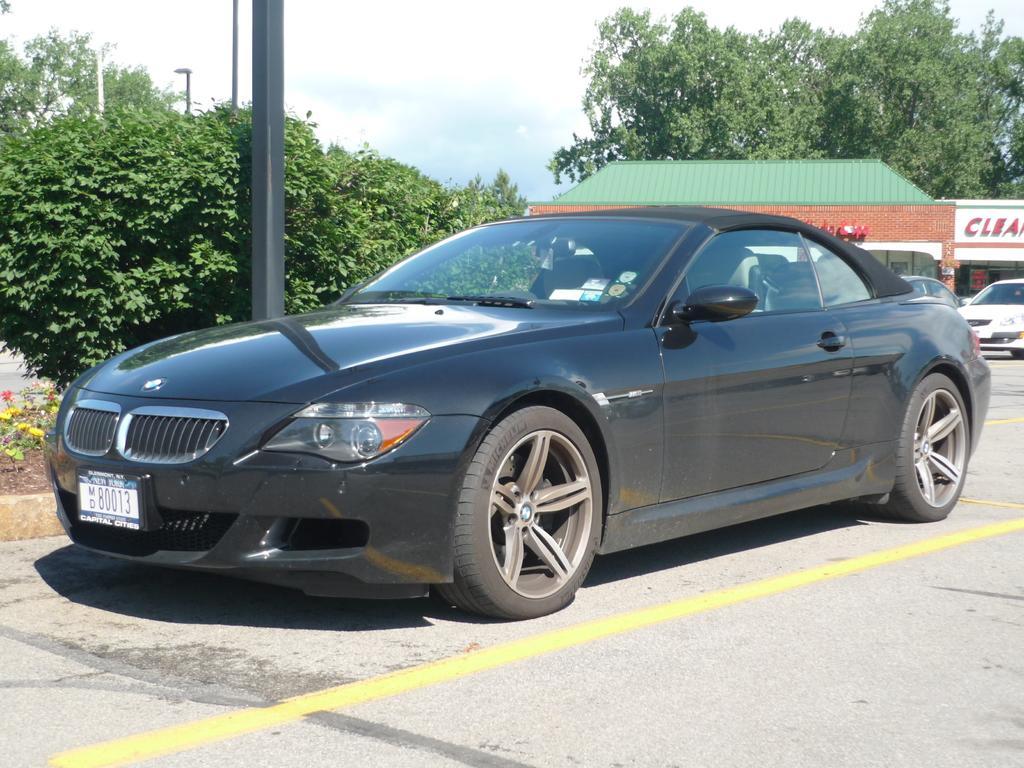Please provide a concise description of this image. In the picture I can see vehicles on the ground among them the car in front of the image is black in color. In the background I can see trees, poles, the sky and some other objects. 